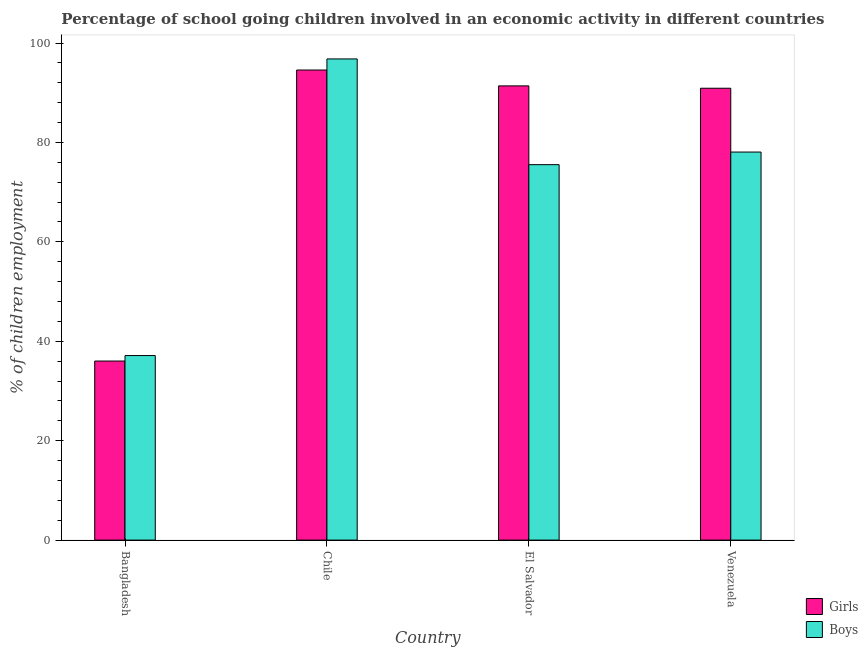How many different coloured bars are there?
Your answer should be very brief. 2. How many groups of bars are there?
Make the answer very short. 4. What is the label of the 3rd group of bars from the left?
Provide a succinct answer. El Salvador. What is the percentage of school going girls in Bangladesh?
Your answer should be compact. 36.02. Across all countries, what is the maximum percentage of school going girls?
Your response must be concise. 94.57. Across all countries, what is the minimum percentage of school going boys?
Provide a succinct answer. 37.13. In which country was the percentage of school going boys minimum?
Ensure brevity in your answer.  Bangladesh. What is the total percentage of school going boys in the graph?
Your response must be concise. 287.54. What is the difference between the percentage of school going boys in Chile and that in Venezuela?
Your answer should be compact. 18.74. What is the difference between the percentage of school going boys in Venezuela and the percentage of school going girls in El Salvador?
Provide a short and direct response. -13.31. What is the average percentage of school going girls per country?
Your response must be concise. 78.22. What is the difference between the percentage of school going boys and percentage of school going girls in Venezuela?
Your answer should be compact. -12.84. In how many countries, is the percentage of school going boys greater than 16 %?
Your answer should be very brief. 4. What is the ratio of the percentage of school going girls in Bangladesh to that in Chile?
Offer a terse response. 0.38. What is the difference between the highest and the second highest percentage of school going girls?
Your answer should be compact. 3.19. What is the difference between the highest and the lowest percentage of school going girls?
Provide a short and direct response. 58.55. Is the sum of the percentage of school going boys in Chile and Venezuela greater than the maximum percentage of school going girls across all countries?
Your answer should be compact. Yes. What does the 1st bar from the left in Venezuela represents?
Offer a very short reply. Girls. What does the 2nd bar from the right in Venezuela represents?
Ensure brevity in your answer.  Girls. How many bars are there?
Your answer should be very brief. 8. Are all the bars in the graph horizontal?
Your answer should be compact. No. How many countries are there in the graph?
Offer a terse response. 4. Are the values on the major ticks of Y-axis written in scientific E-notation?
Provide a short and direct response. No. Does the graph contain grids?
Make the answer very short. No. Where does the legend appear in the graph?
Your response must be concise. Bottom right. How many legend labels are there?
Provide a short and direct response. 2. What is the title of the graph?
Provide a short and direct response. Percentage of school going children involved in an economic activity in different countries. Does "Secondary Education" appear as one of the legend labels in the graph?
Your answer should be very brief. No. What is the label or title of the Y-axis?
Ensure brevity in your answer.  % of children employment. What is the % of children employment of Girls in Bangladesh?
Offer a terse response. 36.02. What is the % of children employment in Boys in Bangladesh?
Ensure brevity in your answer.  37.13. What is the % of children employment in Girls in Chile?
Offer a terse response. 94.57. What is the % of children employment of Boys in Chile?
Offer a terse response. 96.81. What is the % of children employment in Girls in El Salvador?
Offer a terse response. 91.38. What is the % of children employment in Boys in El Salvador?
Ensure brevity in your answer.  75.53. What is the % of children employment of Girls in Venezuela?
Offer a very short reply. 90.91. What is the % of children employment of Boys in Venezuela?
Provide a succinct answer. 78.07. Across all countries, what is the maximum % of children employment in Girls?
Your answer should be compact. 94.57. Across all countries, what is the maximum % of children employment of Boys?
Provide a succinct answer. 96.81. Across all countries, what is the minimum % of children employment in Girls?
Give a very brief answer. 36.02. Across all countries, what is the minimum % of children employment of Boys?
Make the answer very short. 37.13. What is the total % of children employment of Girls in the graph?
Provide a succinct answer. 312.89. What is the total % of children employment of Boys in the graph?
Offer a very short reply. 287.54. What is the difference between the % of children employment in Girls in Bangladesh and that in Chile?
Provide a succinct answer. -58.55. What is the difference between the % of children employment in Boys in Bangladesh and that in Chile?
Provide a succinct answer. -59.68. What is the difference between the % of children employment of Girls in Bangladesh and that in El Salvador?
Your answer should be compact. -55.36. What is the difference between the % of children employment of Boys in Bangladesh and that in El Salvador?
Give a very brief answer. -38.4. What is the difference between the % of children employment of Girls in Bangladesh and that in Venezuela?
Offer a terse response. -54.88. What is the difference between the % of children employment of Boys in Bangladesh and that in Venezuela?
Give a very brief answer. -40.94. What is the difference between the % of children employment in Girls in Chile and that in El Salvador?
Provide a short and direct response. 3.19. What is the difference between the % of children employment of Boys in Chile and that in El Salvador?
Provide a succinct answer. 21.27. What is the difference between the % of children employment of Girls in Chile and that in Venezuela?
Offer a very short reply. 3.67. What is the difference between the % of children employment of Boys in Chile and that in Venezuela?
Keep it short and to the point. 18.74. What is the difference between the % of children employment in Girls in El Salvador and that in Venezuela?
Offer a terse response. 0.47. What is the difference between the % of children employment in Boys in El Salvador and that in Venezuela?
Offer a very short reply. -2.54. What is the difference between the % of children employment of Girls in Bangladesh and the % of children employment of Boys in Chile?
Provide a succinct answer. -60.78. What is the difference between the % of children employment in Girls in Bangladesh and the % of children employment in Boys in El Salvador?
Provide a short and direct response. -39.51. What is the difference between the % of children employment of Girls in Bangladesh and the % of children employment of Boys in Venezuela?
Keep it short and to the point. -42.05. What is the difference between the % of children employment of Girls in Chile and the % of children employment of Boys in El Salvador?
Make the answer very short. 19.04. What is the difference between the % of children employment in Girls in Chile and the % of children employment in Boys in Venezuela?
Your answer should be compact. 16.5. What is the difference between the % of children employment of Girls in El Salvador and the % of children employment of Boys in Venezuela?
Keep it short and to the point. 13.31. What is the average % of children employment in Girls per country?
Your answer should be very brief. 78.22. What is the average % of children employment of Boys per country?
Your answer should be very brief. 71.88. What is the difference between the % of children employment in Girls and % of children employment in Boys in Bangladesh?
Provide a short and direct response. -1.11. What is the difference between the % of children employment of Girls and % of children employment of Boys in Chile?
Provide a short and direct response. -2.23. What is the difference between the % of children employment of Girls and % of children employment of Boys in El Salvador?
Your response must be concise. 15.85. What is the difference between the % of children employment in Girls and % of children employment in Boys in Venezuela?
Your answer should be compact. 12.84. What is the ratio of the % of children employment of Girls in Bangladesh to that in Chile?
Provide a short and direct response. 0.38. What is the ratio of the % of children employment of Boys in Bangladesh to that in Chile?
Provide a succinct answer. 0.38. What is the ratio of the % of children employment in Girls in Bangladesh to that in El Salvador?
Keep it short and to the point. 0.39. What is the ratio of the % of children employment in Boys in Bangladesh to that in El Salvador?
Offer a terse response. 0.49. What is the ratio of the % of children employment in Girls in Bangladesh to that in Venezuela?
Your answer should be very brief. 0.4. What is the ratio of the % of children employment of Boys in Bangladesh to that in Venezuela?
Offer a terse response. 0.48. What is the ratio of the % of children employment of Girls in Chile to that in El Salvador?
Your answer should be compact. 1.03. What is the ratio of the % of children employment in Boys in Chile to that in El Salvador?
Your answer should be compact. 1.28. What is the ratio of the % of children employment in Girls in Chile to that in Venezuela?
Your answer should be very brief. 1.04. What is the ratio of the % of children employment in Boys in Chile to that in Venezuela?
Make the answer very short. 1.24. What is the ratio of the % of children employment in Girls in El Salvador to that in Venezuela?
Offer a terse response. 1.01. What is the ratio of the % of children employment of Boys in El Salvador to that in Venezuela?
Keep it short and to the point. 0.97. What is the difference between the highest and the second highest % of children employment of Girls?
Make the answer very short. 3.19. What is the difference between the highest and the second highest % of children employment in Boys?
Provide a short and direct response. 18.74. What is the difference between the highest and the lowest % of children employment of Girls?
Make the answer very short. 58.55. What is the difference between the highest and the lowest % of children employment in Boys?
Your response must be concise. 59.68. 